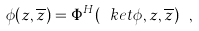<formula> <loc_0><loc_0><loc_500><loc_500>\phi ( z , \overline { z } ) = \Phi ^ { H } ( \ k e t { \phi } , z , \overline { z } ) \ ,</formula> 